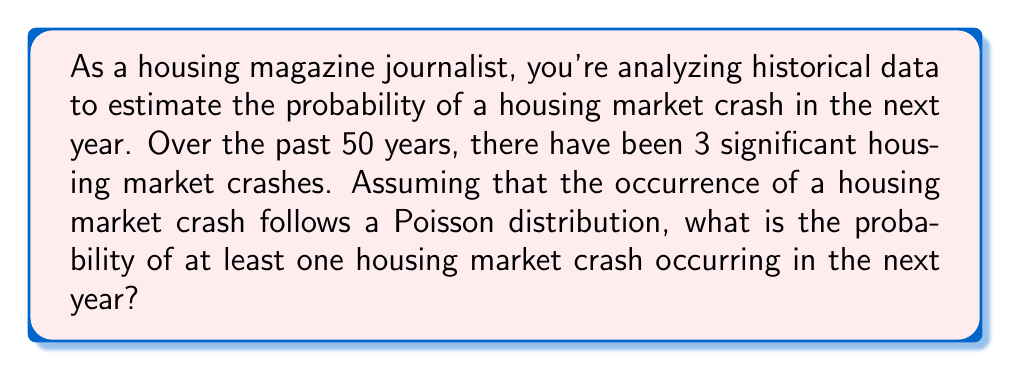Can you solve this math problem? To solve this problem, we'll use the Poisson distribution, which is suitable for modeling rare events over a fixed interval of time. Let's break it down step-by-step:

1. Calculate the rate parameter (λ):
   λ = Number of events / Time period
   λ = 3 crashes / 50 years = 0.06 crashes per year

2. We want to find the probability of at least one crash in the next year. This is equivalent to 1 minus the probability of zero crashes.

3. The Poisson probability mass function is:
   $$ P(X = k) = \frac{e^{-λ} λ^k}{k!} $$
   where k is the number of events, and λ is the rate parameter.

4. For zero crashes (k = 0):
   $$ P(X = 0) = \frac{e^{-0.06} (0.06)^0}{0!} = e^{-0.06} $$

5. The probability of at least one crash is:
   $$ P(X \geq 1) = 1 - P(X = 0) = 1 - e^{-0.06} $$

6. Calculate the final result:
   $$ 1 - e^{-0.06} \approx 1 - 0.9417 \approx 0.0583 $$
Answer: The probability of at least one housing market crash occurring in the next year is approximately 0.0583 or 5.83%. 